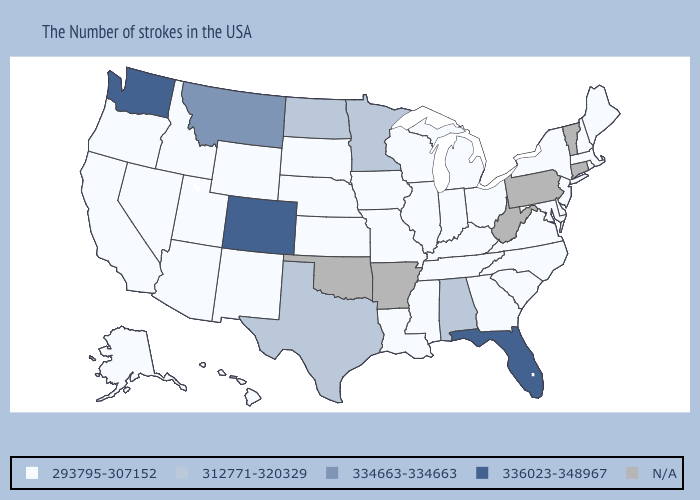What is the value of Oklahoma?
Give a very brief answer. N/A. Name the states that have a value in the range N/A?
Be succinct. Vermont, Connecticut, Pennsylvania, West Virginia, Arkansas, Oklahoma. Which states hav the highest value in the South?
Answer briefly. Florida. Among the states that border Wyoming , which have the highest value?
Answer briefly. Colorado. Among the states that border Wyoming , which have the lowest value?
Give a very brief answer. Nebraska, South Dakota, Utah, Idaho. What is the value of Missouri?
Short answer required. 293795-307152. Among the states that border Delaware , which have the highest value?
Write a very short answer. New Jersey, Maryland. Name the states that have a value in the range N/A?
Short answer required. Vermont, Connecticut, Pennsylvania, West Virginia, Arkansas, Oklahoma. Does the map have missing data?
Be succinct. Yes. Name the states that have a value in the range 293795-307152?
Concise answer only. Maine, Massachusetts, Rhode Island, New Hampshire, New York, New Jersey, Delaware, Maryland, Virginia, North Carolina, South Carolina, Ohio, Georgia, Michigan, Kentucky, Indiana, Tennessee, Wisconsin, Illinois, Mississippi, Louisiana, Missouri, Iowa, Kansas, Nebraska, South Dakota, Wyoming, New Mexico, Utah, Arizona, Idaho, Nevada, California, Oregon, Alaska, Hawaii. Does the first symbol in the legend represent the smallest category?
Write a very short answer. Yes. Name the states that have a value in the range 312771-320329?
Give a very brief answer. Alabama, Minnesota, Texas, North Dakota. 